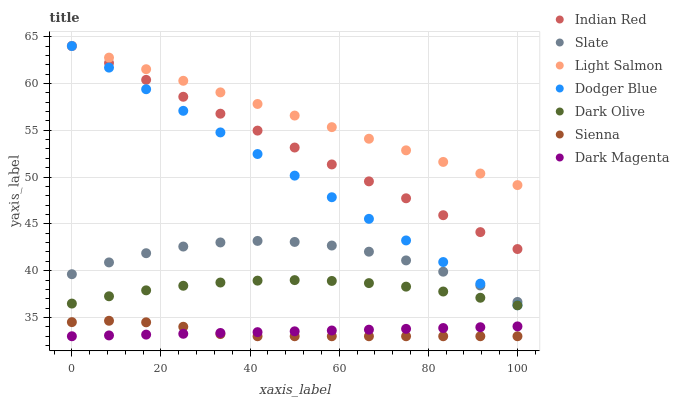Does Sienna have the minimum area under the curve?
Answer yes or no. Yes. Does Light Salmon have the maximum area under the curve?
Answer yes or no. Yes. Does Dark Magenta have the minimum area under the curve?
Answer yes or no. No. Does Dark Magenta have the maximum area under the curve?
Answer yes or no. No. Is Dark Magenta the smoothest?
Answer yes or no. Yes. Is Slate the roughest?
Answer yes or no. Yes. Is Slate the smoothest?
Answer yes or no. No. Is Dark Magenta the roughest?
Answer yes or no. No. Does Dark Magenta have the lowest value?
Answer yes or no. Yes. Does Slate have the lowest value?
Answer yes or no. No. Does Indian Red have the highest value?
Answer yes or no. Yes. Does Slate have the highest value?
Answer yes or no. No. Is Dark Olive less than Slate?
Answer yes or no. Yes. Is Slate greater than Dark Magenta?
Answer yes or no. Yes. Does Indian Red intersect Light Salmon?
Answer yes or no. Yes. Is Indian Red less than Light Salmon?
Answer yes or no. No. Is Indian Red greater than Light Salmon?
Answer yes or no. No. Does Dark Olive intersect Slate?
Answer yes or no. No. 